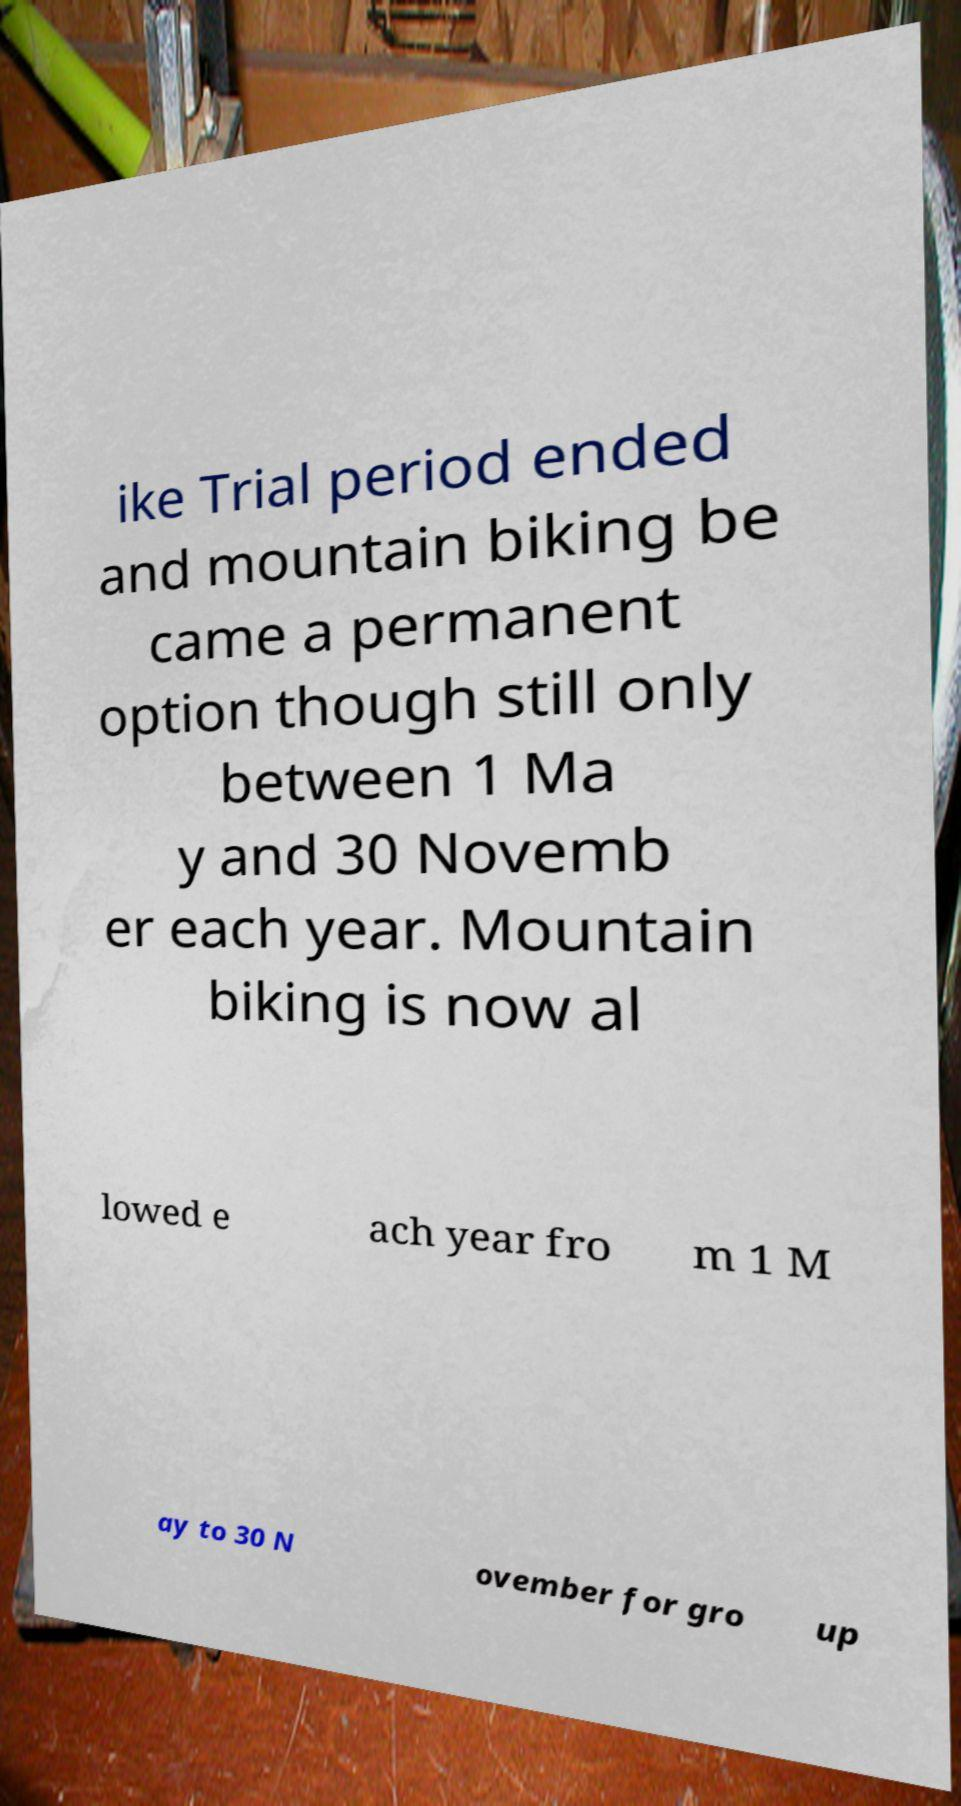Could you assist in decoding the text presented in this image and type it out clearly? ike Trial period ended and mountain biking be came a permanent option though still only between 1 Ma y and 30 Novemb er each year. Mountain biking is now al lowed e ach year fro m 1 M ay to 30 N ovember for gro up 